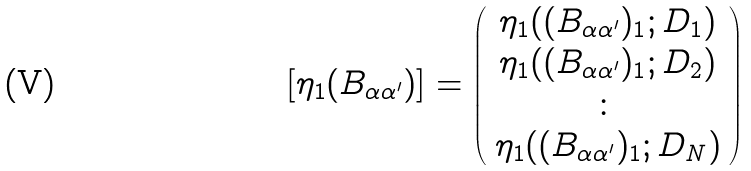Convert formula to latex. <formula><loc_0><loc_0><loc_500><loc_500>[ \eta _ { 1 } ( B _ { \alpha \alpha ^ { \prime } } ) ] = \left ( \begin{array} { c } \eta _ { 1 } ( ( B _ { \alpha \alpha ^ { \prime } } ) _ { 1 } ; D _ { 1 } ) \\ \eta _ { 1 } ( ( B _ { \alpha \alpha ^ { \prime } } ) _ { 1 } ; D _ { 2 } ) \\ \colon \\ \eta _ { 1 } ( ( B _ { \alpha \alpha ^ { \prime } } ) _ { 1 } ; D _ { N } ) \end{array} \right )</formula> 